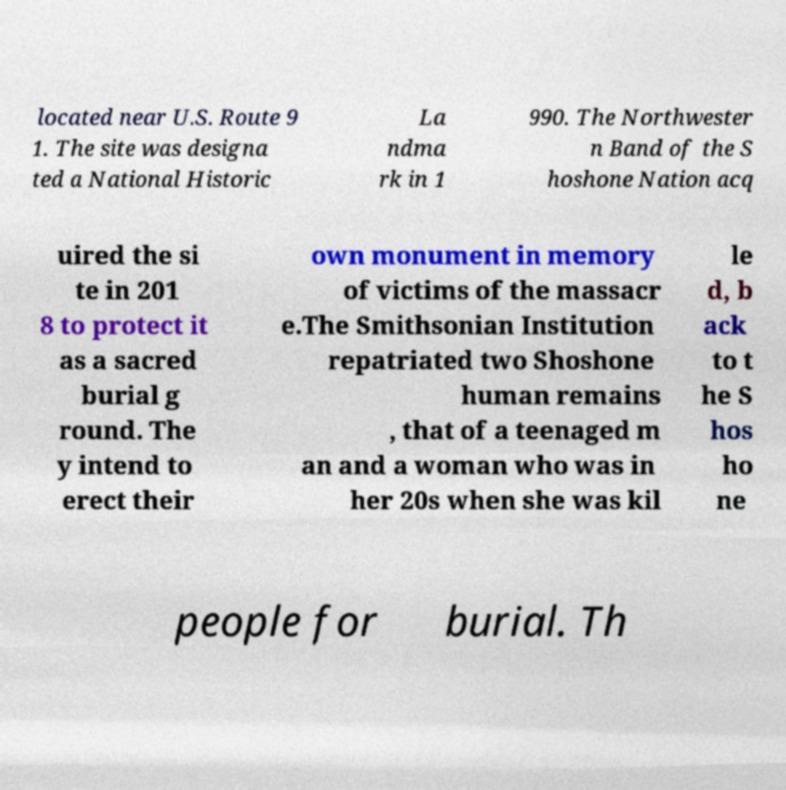Please identify and transcribe the text found in this image. located near U.S. Route 9 1. The site was designa ted a National Historic La ndma rk in 1 990. The Northwester n Band of the S hoshone Nation acq uired the si te in 201 8 to protect it as a sacred burial g round. The y intend to erect their own monument in memory of victims of the massacr e.The Smithsonian Institution repatriated two Shoshone human remains , that of a teenaged m an and a woman who was in her 20s when she was kil le d, b ack to t he S hos ho ne people for burial. Th 